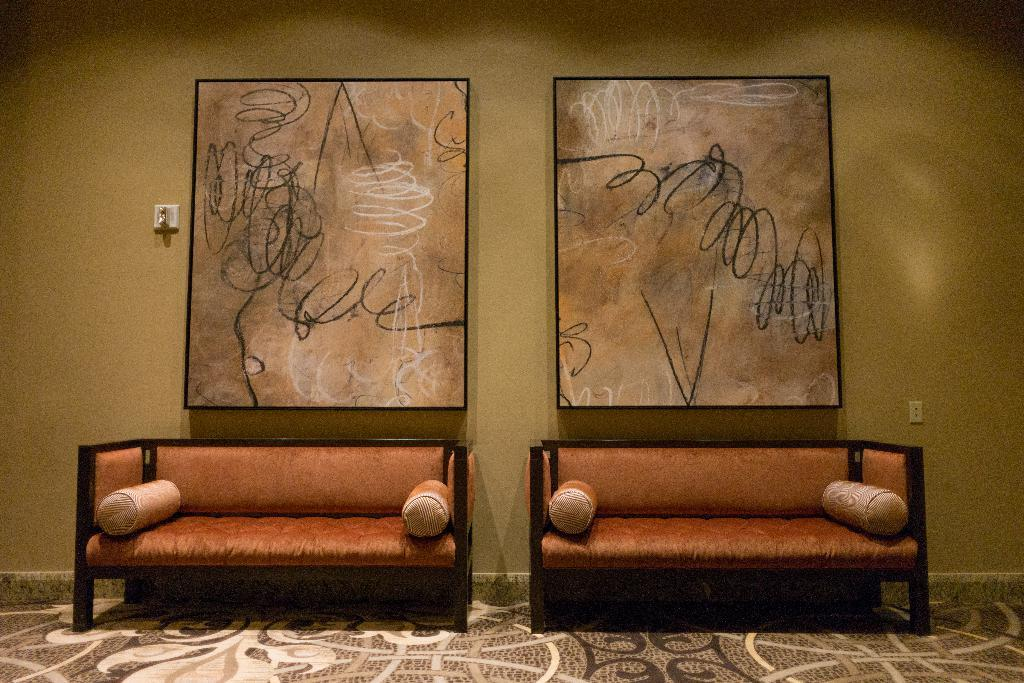What type of structure can be seen in the image? There is a wall in the image. What device is present on the wall? There is a switch board in the image. Are there any decorative items on the wall? Yes, there are photo frames in the image. How many seating options are visible in the image? There are two sofas in the image. How many ducks are sitting on the sofas in the image? There are no ducks present in the image; it only features a wall, a switch board, photo frames, and two sofas. 